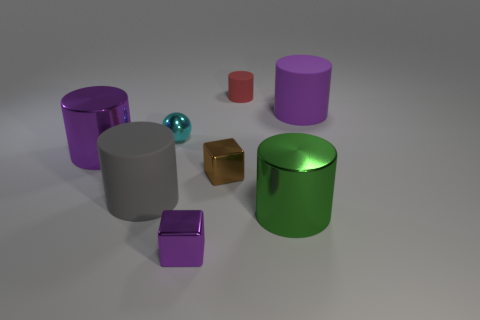Is the purple cylinder that is on the left side of the green object made of the same material as the brown object in front of the small red cylinder?
Provide a short and direct response. Yes. There is a large gray thing that is the same shape as the tiny red object; what is it made of?
Ensure brevity in your answer.  Rubber. Do the big green cylinder and the gray thing have the same material?
Offer a terse response. No. The large cylinder on the right side of the metal cylinder that is to the right of the tiny ball is what color?
Ensure brevity in your answer.  Purple. What size is the purple thing that is made of the same material as the small red cylinder?
Provide a succinct answer. Large. What number of brown things have the same shape as the small purple metallic object?
Your answer should be very brief. 1. How many things are large matte cylinders that are on the left side of the tiny red thing or objects behind the large purple matte cylinder?
Ensure brevity in your answer.  2. How many green shiny cylinders are behind the big purple metal thing in front of the small cylinder?
Ensure brevity in your answer.  0. There is a matte object that is to the right of the green shiny thing; is its shape the same as the small purple object that is on the left side of the brown metal cube?
Give a very brief answer. No. Are there any small brown blocks made of the same material as the cyan thing?
Your answer should be compact. Yes. 